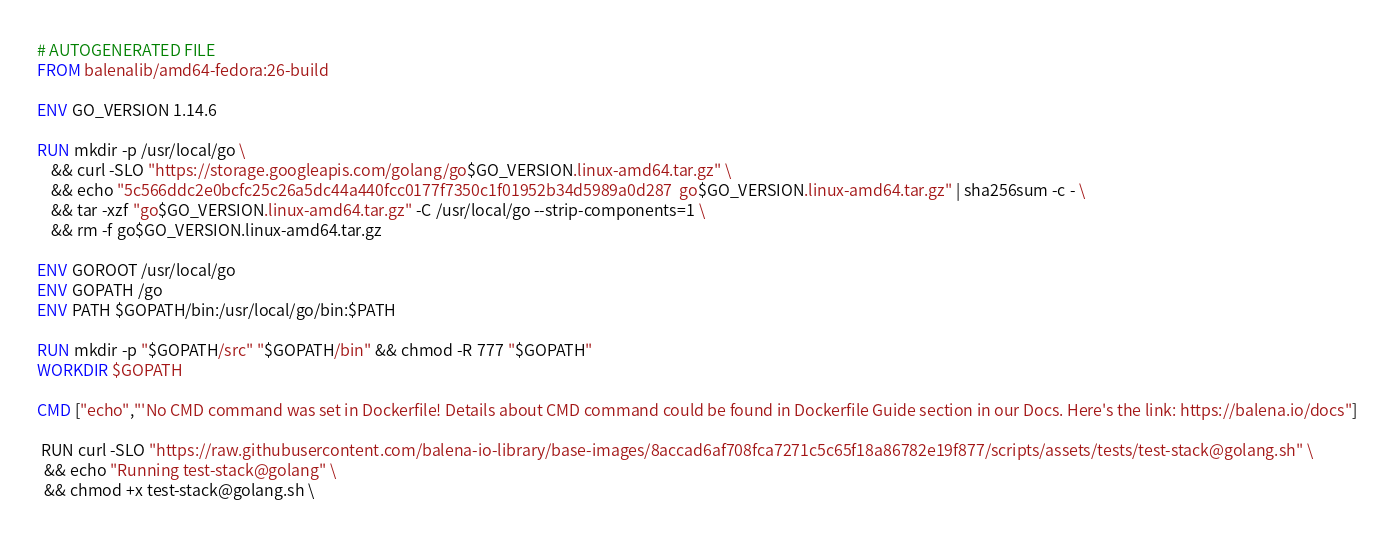Convert code to text. <code><loc_0><loc_0><loc_500><loc_500><_Dockerfile_># AUTOGENERATED FILE
FROM balenalib/amd64-fedora:26-build

ENV GO_VERSION 1.14.6

RUN mkdir -p /usr/local/go \
	&& curl -SLO "https://storage.googleapis.com/golang/go$GO_VERSION.linux-amd64.tar.gz" \
	&& echo "5c566ddc2e0bcfc25c26a5dc44a440fcc0177f7350c1f01952b34d5989a0d287  go$GO_VERSION.linux-amd64.tar.gz" | sha256sum -c - \
	&& tar -xzf "go$GO_VERSION.linux-amd64.tar.gz" -C /usr/local/go --strip-components=1 \
	&& rm -f go$GO_VERSION.linux-amd64.tar.gz

ENV GOROOT /usr/local/go
ENV GOPATH /go
ENV PATH $GOPATH/bin:/usr/local/go/bin:$PATH

RUN mkdir -p "$GOPATH/src" "$GOPATH/bin" && chmod -R 777 "$GOPATH"
WORKDIR $GOPATH

CMD ["echo","'No CMD command was set in Dockerfile! Details about CMD command could be found in Dockerfile Guide section in our Docs. Here's the link: https://balena.io/docs"]

 RUN curl -SLO "https://raw.githubusercontent.com/balena-io-library/base-images/8accad6af708fca7271c5c65f18a86782e19f877/scripts/assets/tests/test-stack@golang.sh" \
  && echo "Running test-stack@golang" \
  && chmod +x test-stack@golang.sh \</code> 